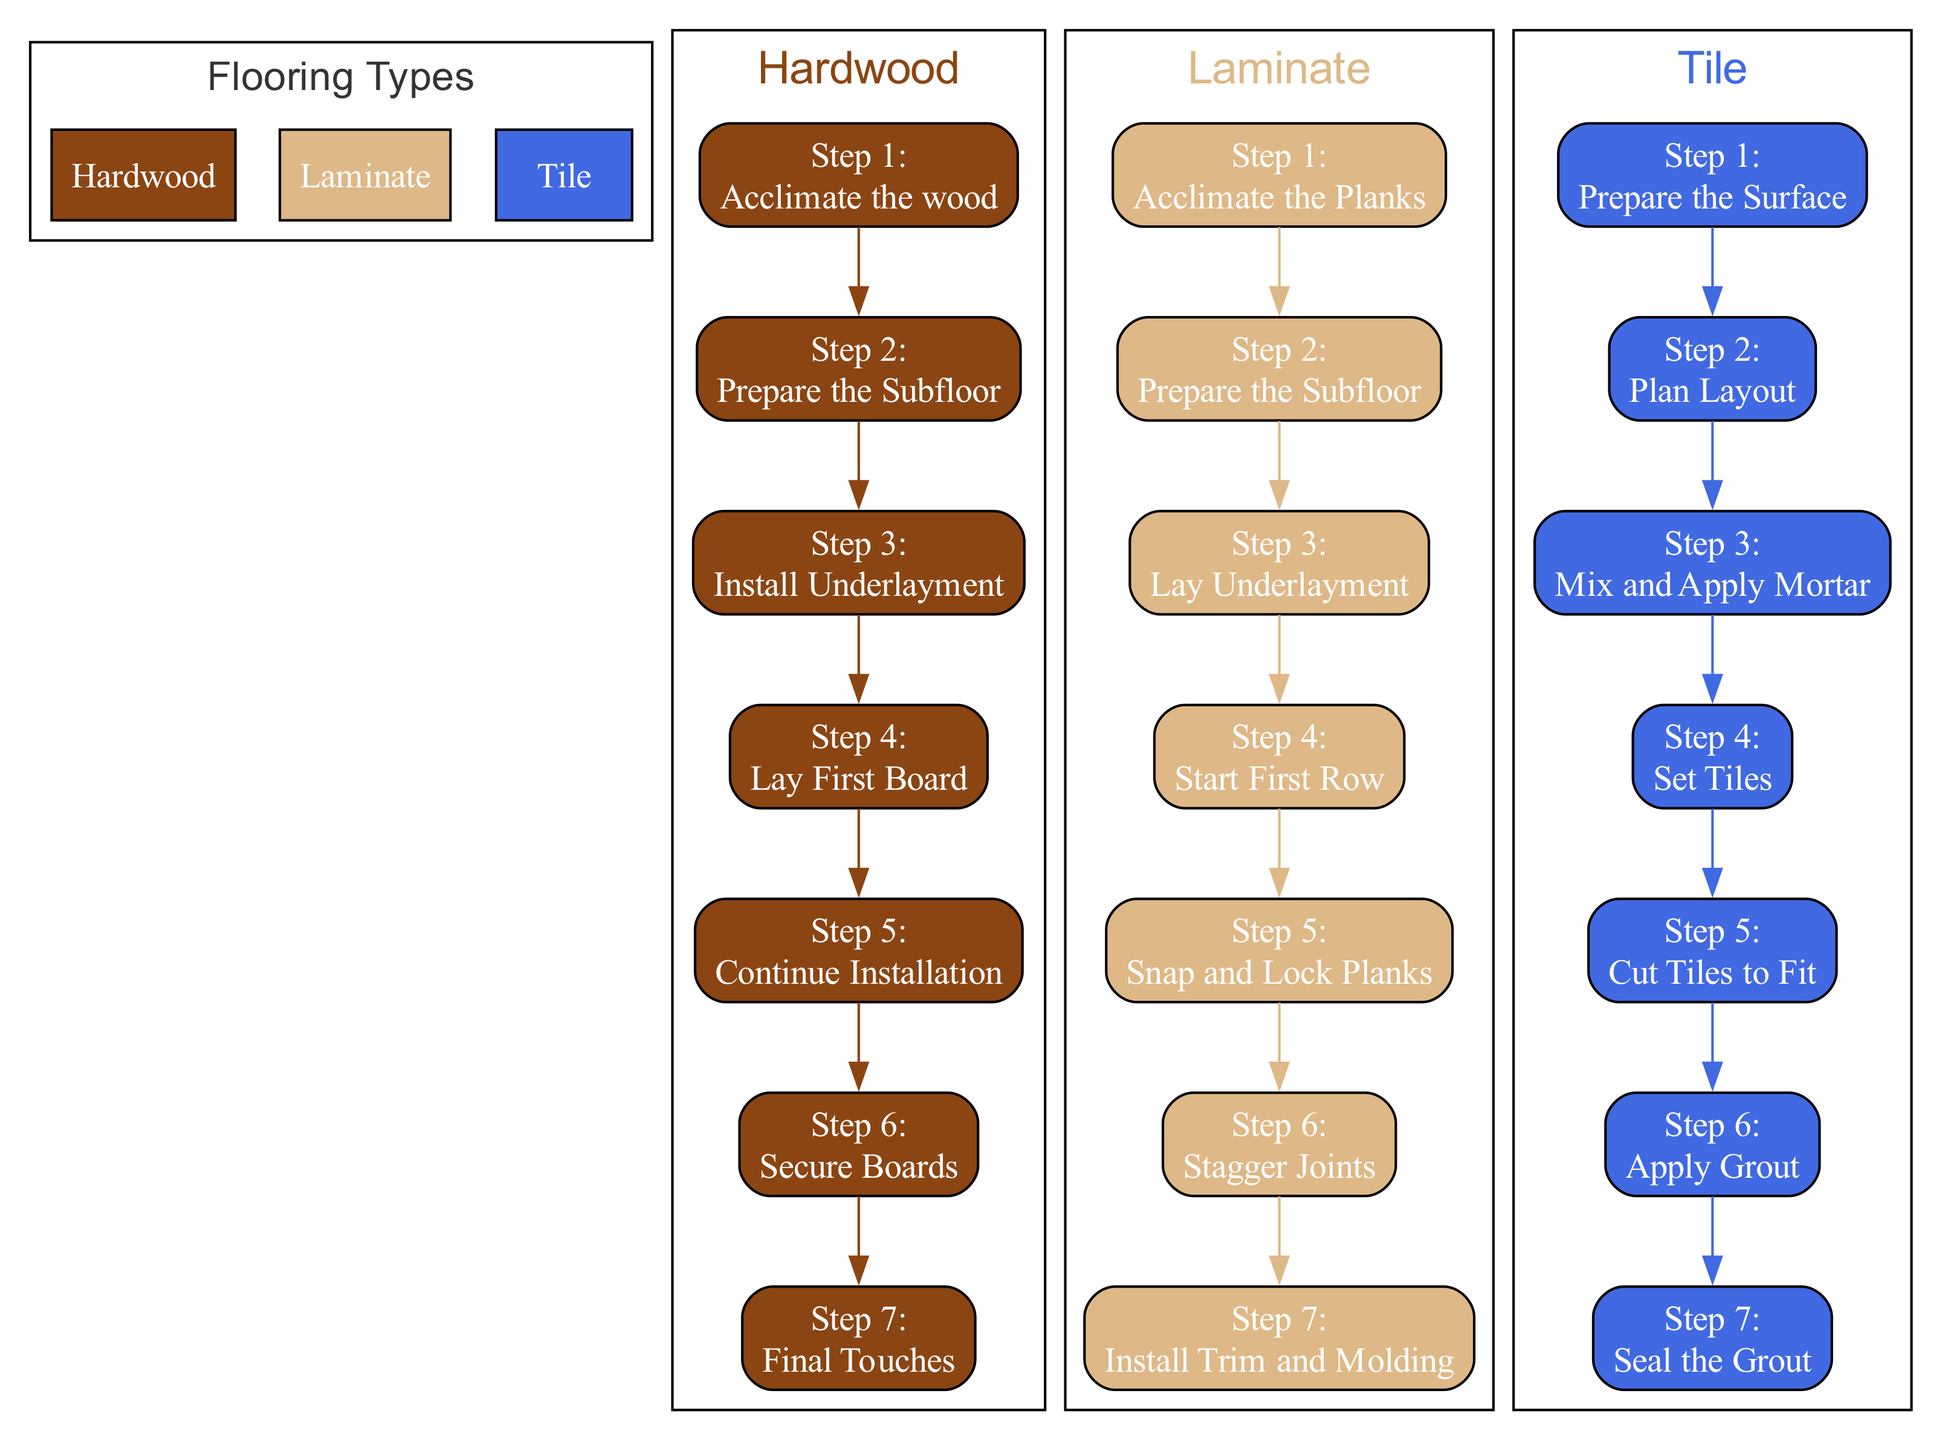What is the first step for installing hardwood flooring? The first step listed under the hardwood flooring installation is "Acclimate the wood." According to the diagram, it specifies that hardwood planks should be stored in the installation area for 3-5 days.
Answer: Acclimate the wood How many steps are involved in the laminate flooring installation? By counting the steps under the laminate flooring section of the diagram, we find there are 7 steps, clearly indicated next to each description.
Answer: 7 What is the final step in the tile installation process? The last step outlined for tile installation is "Seal the grout." This is the concluding action shown in the tile section of the diagram.
Answer: Seal the grout Which flooring type requires a moisture barrier or underlayment during installation? The description for hardwood flooring mentions the need to "Lay Underlayment" if required, which indicates that moisture barriers might be necessary for this type. Therefore, the answer is hardwood.
Answer: Hardwood What is the main purpose of using spacers during laminate installation? In the diagram, it states that spacers are placed along walls to maintain an expansion gap. This ensures proper spacing for the laminate planks as they expand and contract with temperature changes.
Answer: Maintain an expansion gap How do you ensure stability when installing laminate flooring? The diagram specifies that it's essential to "Stagger joints" during installation, which helps in providing stability to ensure that the joints do not line up in a straight line, reducing the risk of damage or gaps.
Answer: Stagger joints Which flooring type begins with "Prepare the Subfloor"? The diagram lists "Prepare the Subfloor" as the second step for both hardwood and laminate flooring, making it common to both types. Therefore, both could be answered as they start with this step.
Answer: Hardwood, Laminate What step follows "Cut Tiles to Fit" in the tile installation process? According to the order in the diagram, the step that follows after "Cut Tiles to Fit" is "Apply Grout." This continuation indicates the sequence of actions in the installation process.
Answer: Apply Grout 